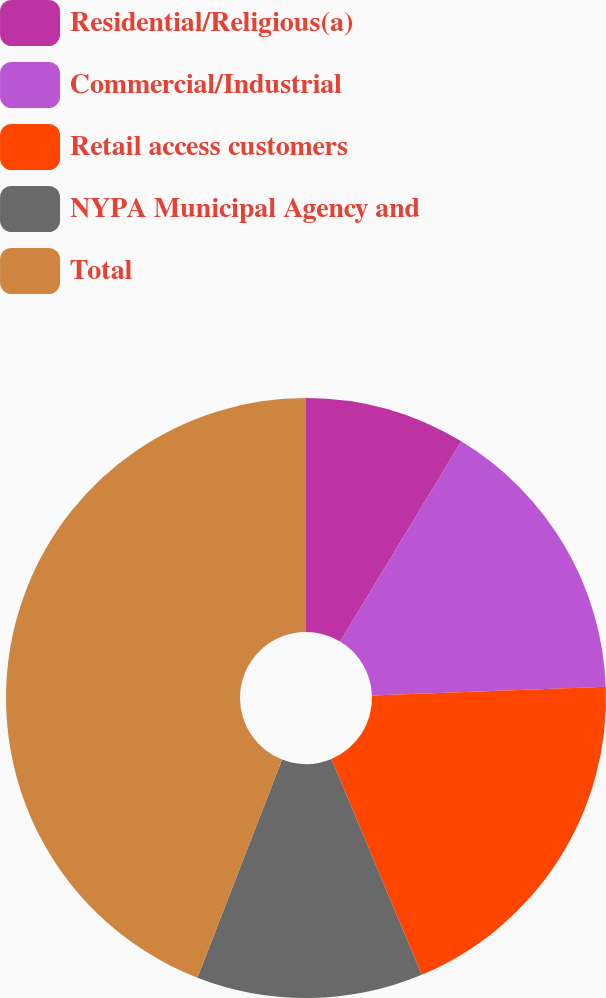Convert chart. <chart><loc_0><loc_0><loc_500><loc_500><pie_chart><fcel>Residential/Religious(a)<fcel>Commercial/Industrial<fcel>Retail access customers<fcel>NYPA Municipal Agency and<fcel>Total<nl><fcel>8.66%<fcel>15.75%<fcel>19.29%<fcel>12.2%<fcel>44.11%<nl></chart> 